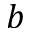Convert formula to latex. <formula><loc_0><loc_0><loc_500><loc_500>b</formula> 